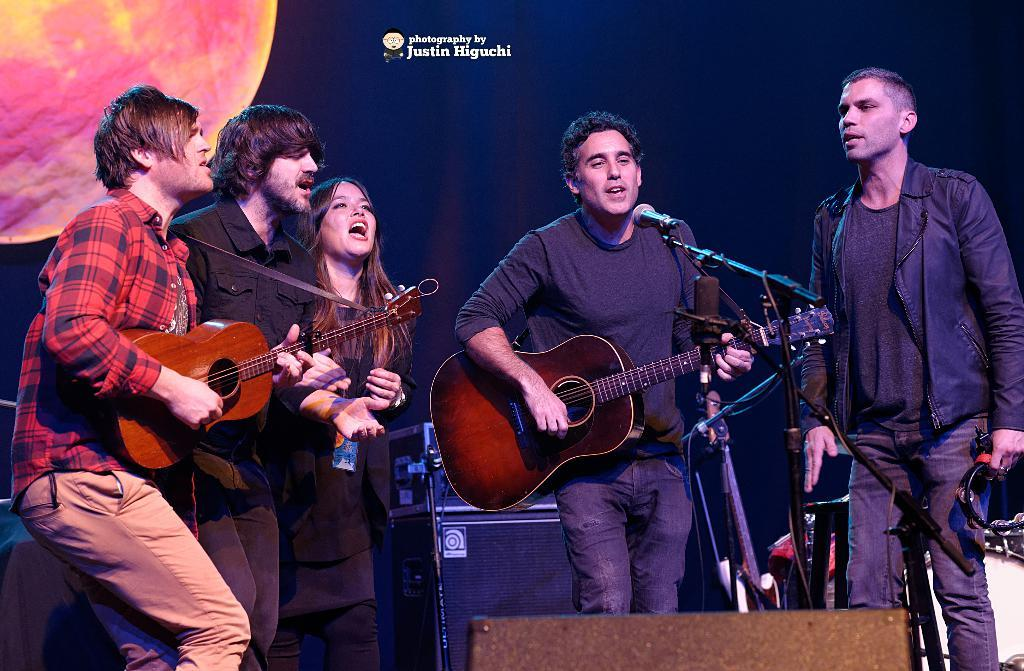How many people are in the image? There are five people in the image, including four men and one woman. What are the people in the image doing? They are all playing musical instruments. Can you describe any equipment in the image? Yes, there is a microphone in the image. What can be seen in the background of the image? There is a poster in the background of the image. What type of star can be seen shining brightly in the image? There is no star visible in the image; it is an indoor scene with people playing musical instruments. What kind of bait is being used to attract the audience in the image? There is no bait present in the image; the people are attracting the audience through their musical performance. 